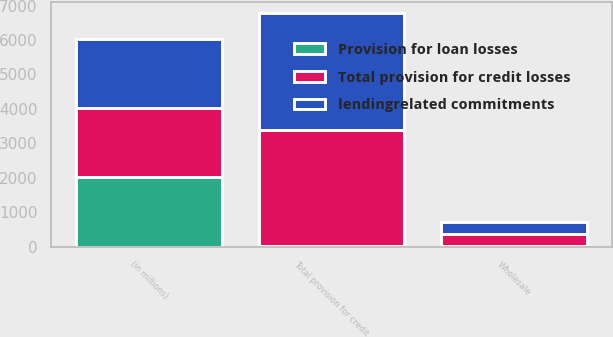Convert chart. <chart><loc_0><loc_0><loc_500><loc_500><stacked_bar_chart><ecel><fcel>(in millions)<fcel>Wholesale<fcel>Total provision for credit<nl><fcel>lendingrelated commitments<fcel>2012<fcel>359<fcel>3387<nl><fcel>Provision for loan losses<fcel>2012<fcel>2<fcel>2<nl><fcel>Total provision for credit losses<fcel>2012<fcel>361<fcel>3385<nl></chart> 